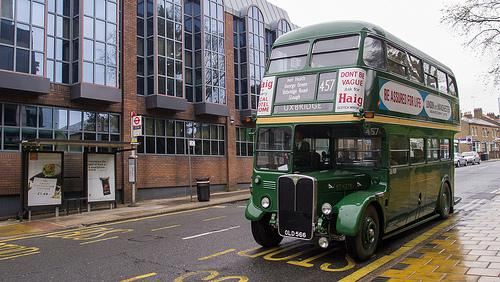Question: where was the photo taken?
Choices:
A. On a city street.
B. On the corner.
C. On the block.
D. In the alley.
Answer with the letter. Answer: A Question: who drives the bus?
Choices:
A. The bus driver.
B. A bear.
C. A woman.
D. A student.
Answer with the letter. Answer: A Question: how many buses are there?
Choices:
A. Two.
B. Three.
C. Four.
D. One.
Answer with the letter. Answer: D 